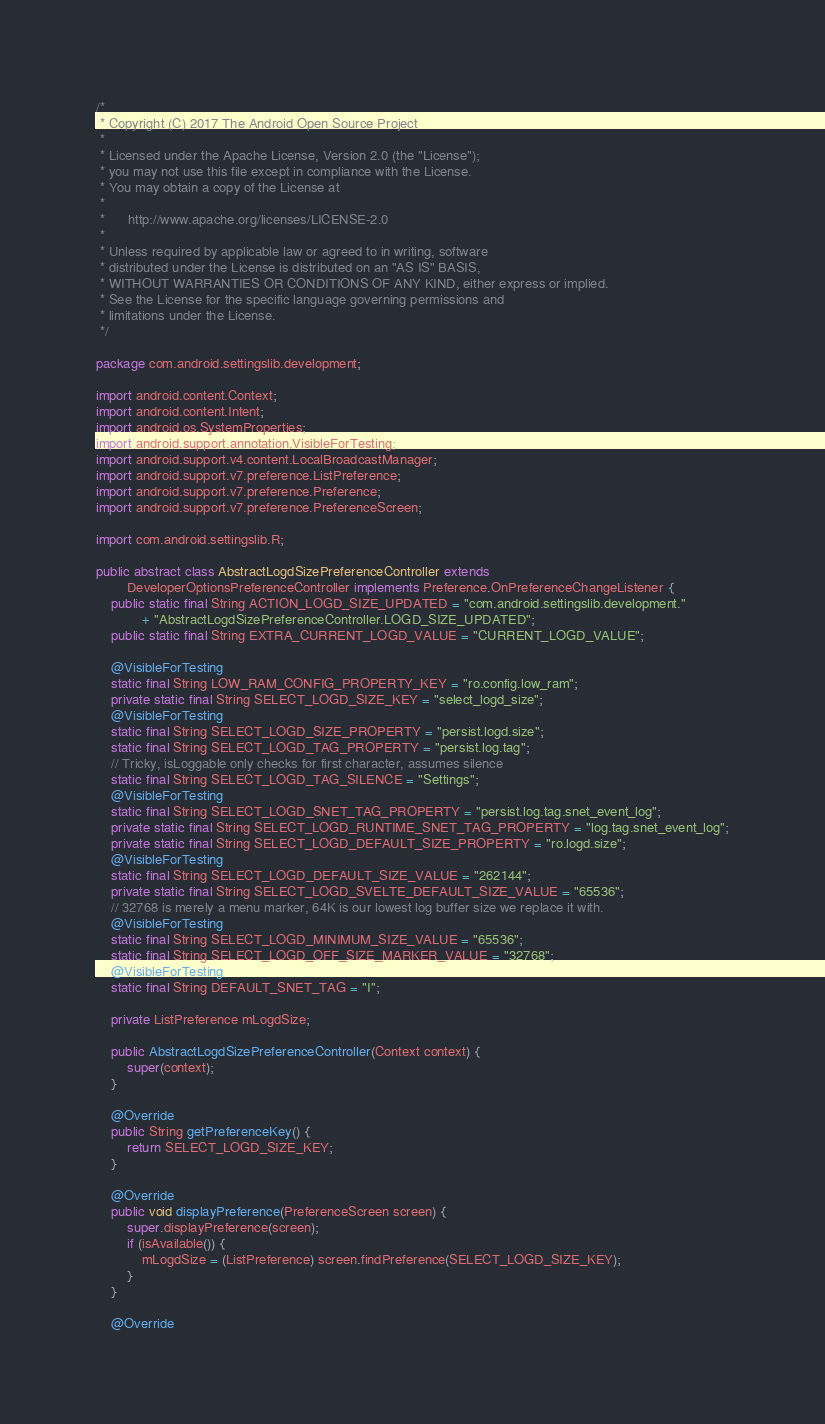<code> <loc_0><loc_0><loc_500><loc_500><_Java_>/*
 * Copyright (C) 2017 The Android Open Source Project
 *
 * Licensed under the Apache License, Version 2.0 (the "License");
 * you may not use this file except in compliance with the License.
 * You may obtain a copy of the License at
 *
 *      http://www.apache.org/licenses/LICENSE-2.0
 *
 * Unless required by applicable law or agreed to in writing, software
 * distributed under the License is distributed on an "AS IS" BASIS,
 * WITHOUT WARRANTIES OR CONDITIONS OF ANY KIND, either express or implied.
 * See the License for the specific language governing permissions and
 * limitations under the License.
 */

package com.android.settingslib.development;

import android.content.Context;
import android.content.Intent;
import android.os.SystemProperties;
import android.support.annotation.VisibleForTesting;
import android.support.v4.content.LocalBroadcastManager;
import android.support.v7.preference.ListPreference;
import android.support.v7.preference.Preference;
import android.support.v7.preference.PreferenceScreen;

import com.android.settingslib.R;

public abstract class AbstractLogdSizePreferenceController extends
        DeveloperOptionsPreferenceController implements Preference.OnPreferenceChangeListener {
    public static final String ACTION_LOGD_SIZE_UPDATED = "com.android.settingslib.development."
            + "AbstractLogdSizePreferenceController.LOGD_SIZE_UPDATED";
    public static final String EXTRA_CURRENT_LOGD_VALUE = "CURRENT_LOGD_VALUE";

    @VisibleForTesting
    static final String LOW_RAM_CONFIG_PROPERTY_KEY = "ro.config.low_ram";
    private static final String SELECT_LOGD_SIZE_KEY = "select_logd_size";
    @VisibleForTesting
    static final String SELECT_LOGD_SIZE_PROPERTY = "persist.logd.size";
    static final String SELECT_LOGD_TAG_PROPERTY = "persist.log.tag";
    // Tricky, isLoggable only checks for first character, assumes silence
    static final String SELECT_LOGD_TAG_SILENCE = "Settings";
    @VisibleForTesting
    static final String SELECT_LOGD_SNET_TAG_PROPERTY = "persist.log.tag.snet_event_log";
    private static final String SELECT_LOGD_RUNTIME_SNET_TAG_PROPERTY = "log.tag.snet_event_log";
    private static final String SELECT_LOGD_DEFAULT_SIZE_PROPERTY = "ro.logd.size";
    @VisibleForTesting
    static final String SELECT_LOGD_DEFAULT_SIZE_VALUE = "262144";
    private static final String SELECT_LOGD_SVELTE_DEFAULT_SIZE_VALUE = "65536";
    // 32768 is merely a menu marker, 64K is our lowest log buffer size we replace it with.
    @VisibleForTesting
    static final String SELECT_LOGD_MINIMUM_SIZE_VALUE = "65536";
    static final String SELECT_LOGD_OFF_SIZE_MARKER_VALUE = "32768";
    @VisibleForTesting
    static final String DEFAULT_SNET_TAG = "I";

    private ListPreference mLogdSize;

    public AbstractLogdSizePreferenceController(Context context) {
        super(context);
    }

    @Override
    public String getPreferenceKey() {
        return SELECT_LOGD_SIZE_KEY;
    }

    @Override
    public void displayPreference(PreferenceScreen screen) {
        super.displayPreference(screen);
        if (isAvailable()) {
            mLogdSize = (ListPreference) screen.findPreference(SELECT_LOGD_SIZE_KEY);
        }
    }

    @Override</code> 